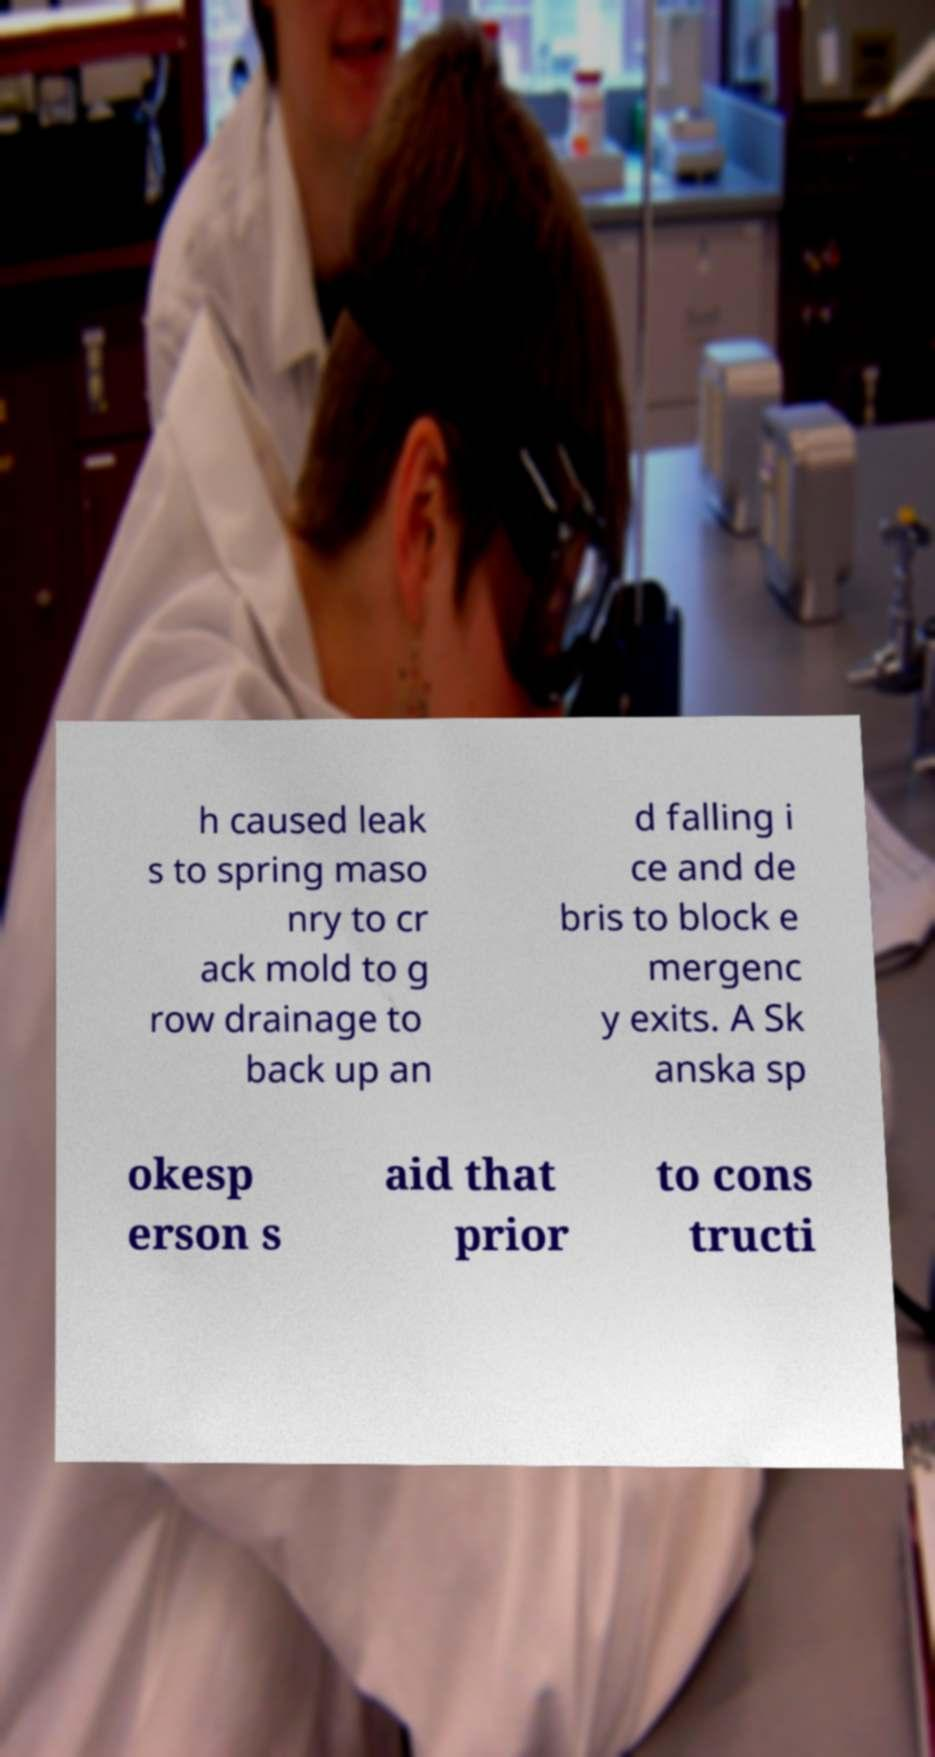There's text embedded in this image that I need extracted. Can you transcribe it verbatim? h caused leak s to spring maso nry to cr ack mold to g row drainage to back up an d falling i ce and de bris to block e mergenc y exits. A Sk anska sp okesp erson s aid that prior to cons tructi 